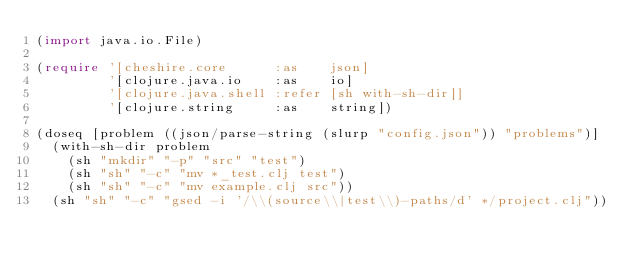<code> <loc_0><loc_0><loc_500><loc_500><_Clojure_>(import java.io.File)

(require '[cheshire.core      :as    json]
         '[clojure.java.io    :as    io]
         '[clojure.java.shell :refer [sh with-sh-dir]]
         '[clojure.string     :as    string])

(doseq [problem ((json/parse-string (slurp "config.json")) "problems")]
  (with-sh-dir problem
    (sh "mkdir" "-p" "src" "test")
    (sh "sh" "-c" "mv *_test.clj test")
    (sh "sh" "-c" "mv example.clj src"))
  (sh "sh" "-c" "gsed -i '/\\(source\\|test\\)-paths/d' */project.clj"))
</code> 